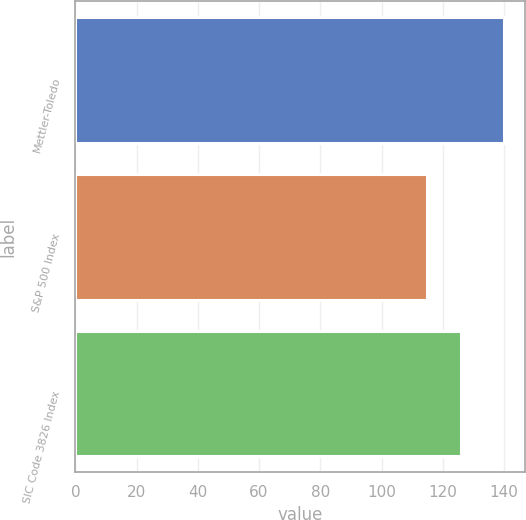<chart> <loc_0><loc_0><loc_500><loc_500><bar_chart><fcel>Mettler-Toledo<fcel>S&P 500 Index<fcel>SIC Code 3826 Index<nl><fcel>140<fcel>115<fcel>126<nl></chart> 